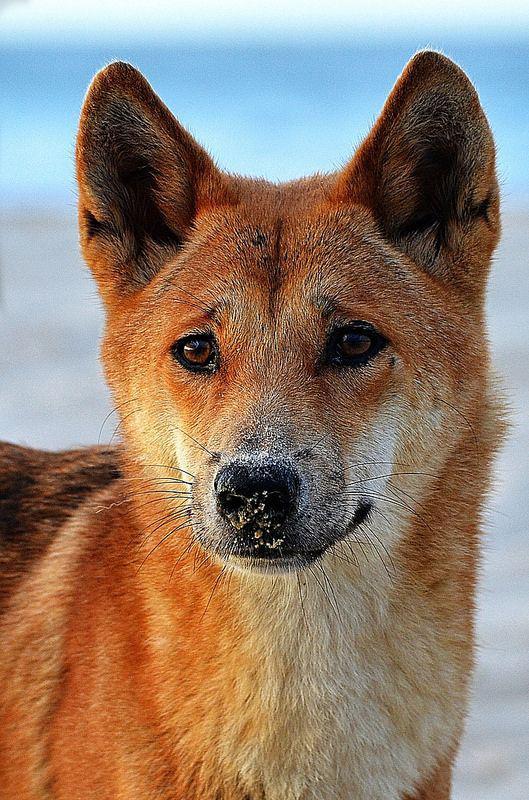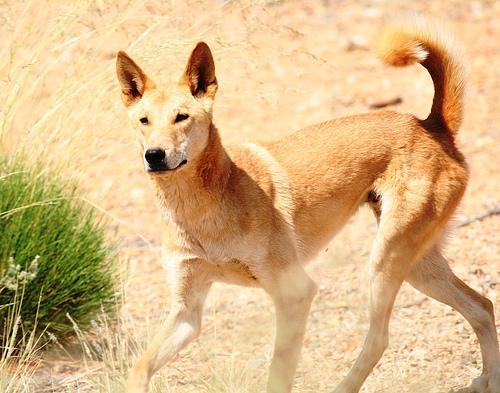The first image is the image on the left, the second image is the image on the right. Considering the images on both sides, is "At least one of the dogs is in front of a large body of water." valid? Answer yes or no. Yes. The first image is the image on the left, the second image is the image on the right. Analyze the images presented: Is the assertion "In at least one of the images, there is a large body of water in the background." valid? Answer yes or no. Yes. 